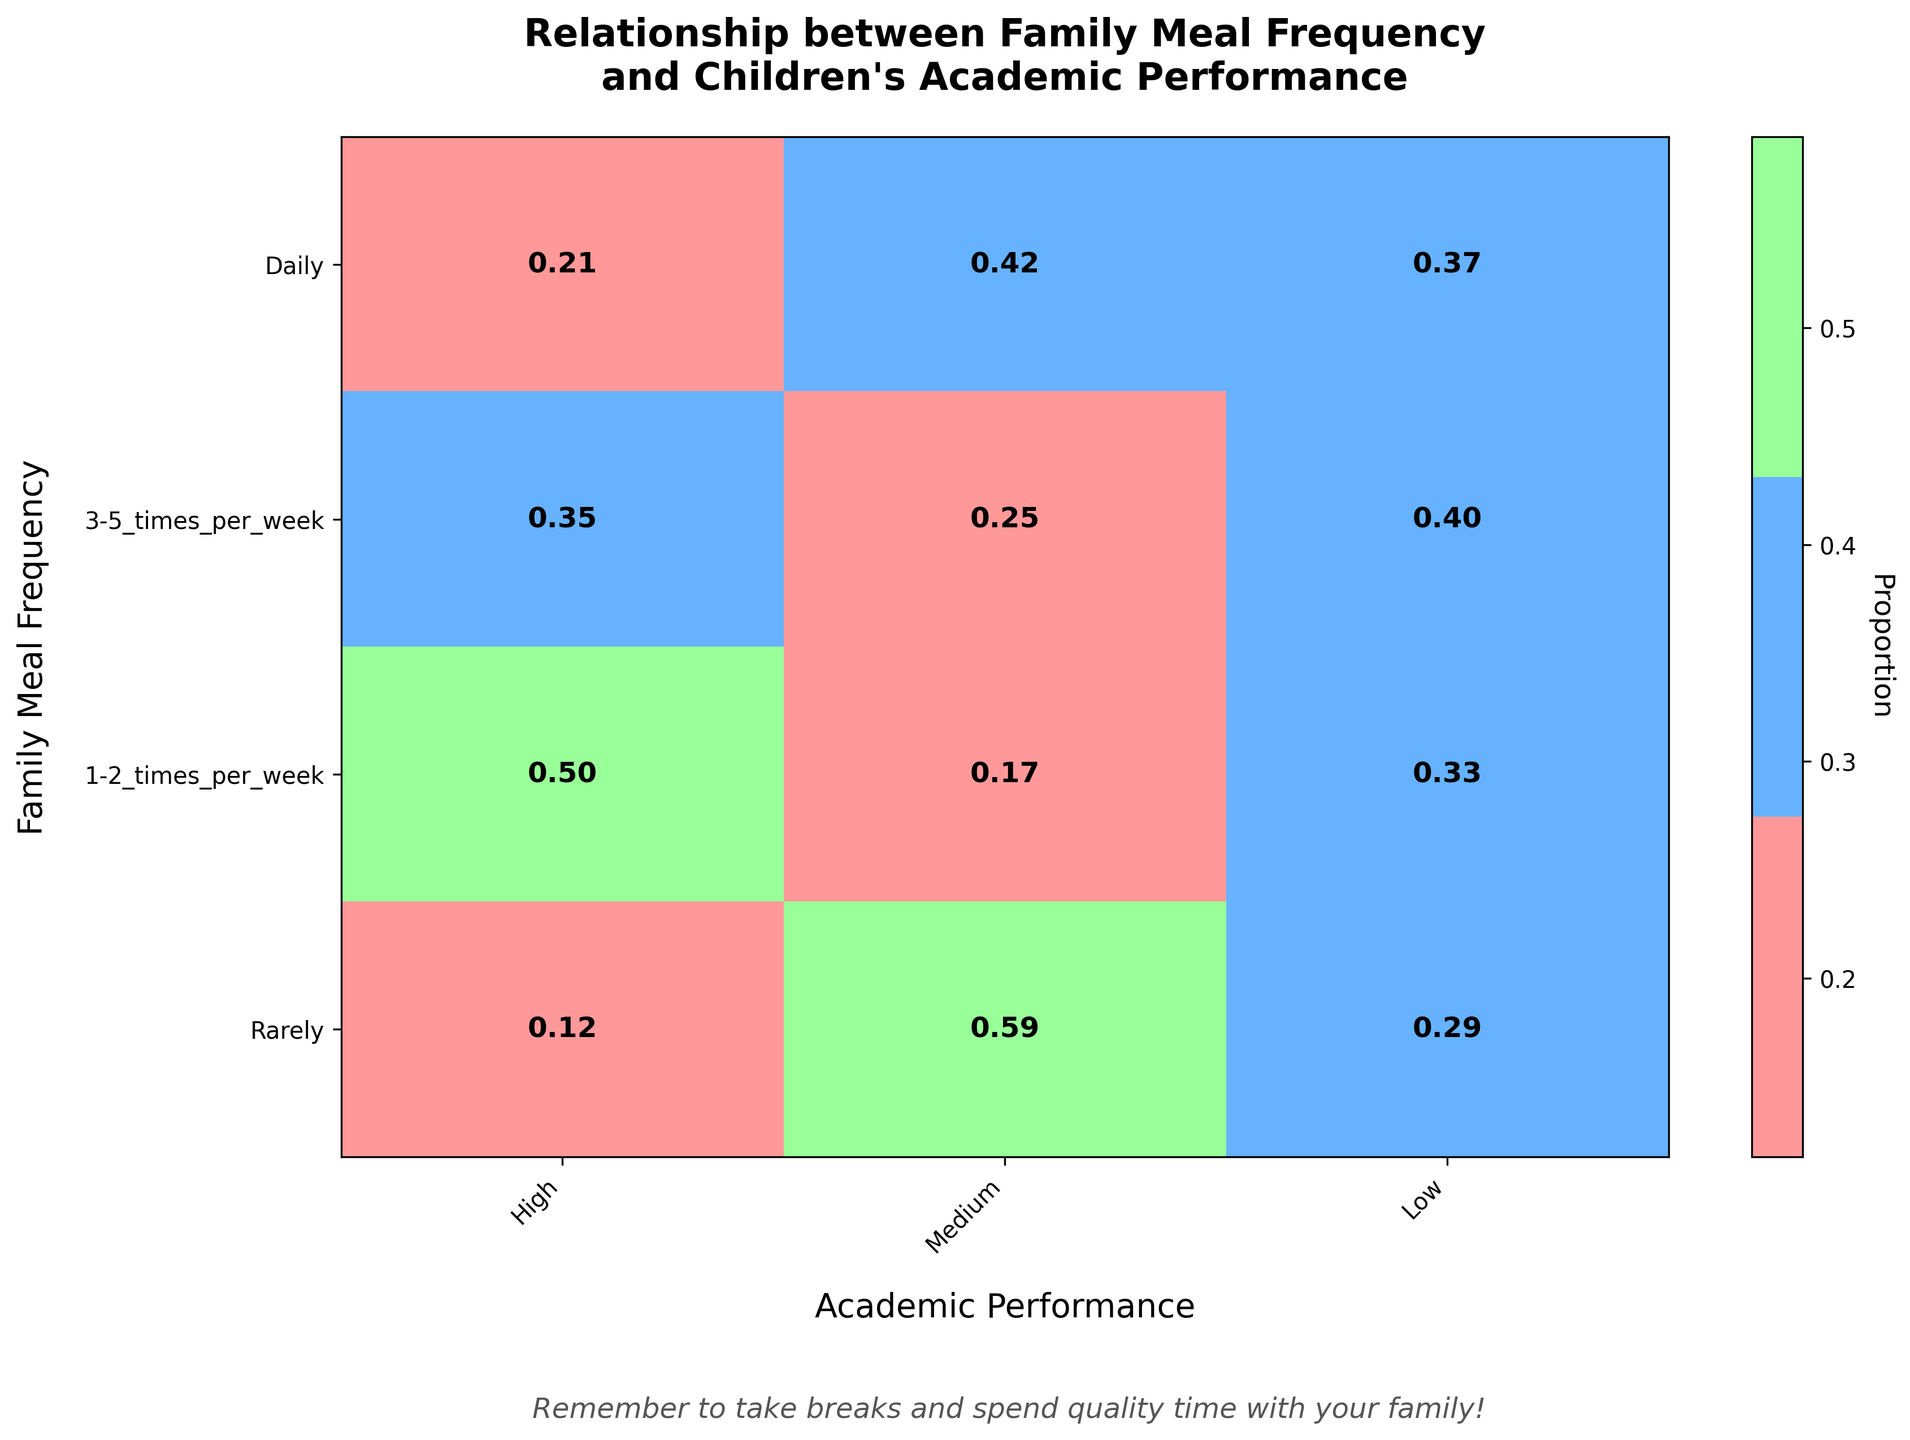What is the title of the plot? The title is usually placed at the top of the plot and is easily readable. It describes the overall content of the figure.
Answer: Relationship between Family Meal Frequency and Children's Academic Performance What is the color used for 'High' academic performance? In the plot, different academic performances are represented with distinct colors. By looking at the color legend or color bars of 'High', you will see the corresponding color.
Answer: Red Which family meal frequency category has the highest proportion of children with 'Low' academic performance? Look at the row labels for different family meal frequencies, and find the highest value in the 'Low' academic performance column in terms of proportion.
Answer: Rarely Among the children who have family meals 1-2 times per week, how does the proportion of 'Medium' academic performance compare to 'High'? Find the row for '1-2 times per week' and compare the proportions in the 'Medium' and 'High' columns. The one with the higher numerical value has a greater proportion.
Answer: Medium is higher Does having daily family meals correlate with better academic performance? Check the proportions of 'High' and 'Medium' academic performance for the 'Daily' family meal frequency to see if they are significantly high, indicating a positive correlation.
Answer: Yes Which family meal frequency category shows a roughly equal proportion of children with 'High' and 'Medium' academic performance? Compare the 'High' and 'Medium' proportions within each family meal frequency row to identify the one where these proportions are approximately equal.
Answer: 3-5 times per week How many different family meal frequency categories are represented in the plot? Count the unique row labels indicating different frequencies of family meals to determine the total number of categories.
Answer: Four What is the proportion of children with 'High' academic performance among those who rarely have family meals? Look for the corresponding proportion by finding the row labeled 'Rarely' and the column for 'High' academic performance.
Answer: 0.10 In which family meal frequency category is 'Low' academic performance the least common? Locate the smallest proportion in the 'Low' academic performance column and identify the corresponding family meal frequency.
Answer: Daily Which academic performance category has the most consistent proportion across all family meal frequencies? Determine which academic performance category (High, Medium, Low) shows the most similar proportions in each family meal frequency row.
Answer: Medium 